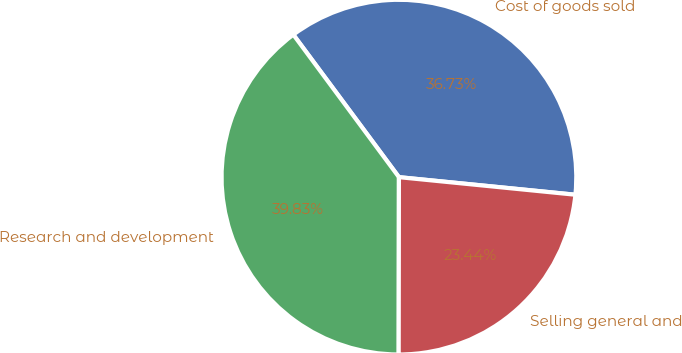<chart> <loc_0><loc_0><loc_500><loc_500><pie_chart><fcel>Cost of goods sold<fcel>Research and development<fcel>Selling general and<nl><fcel>36.73%<fcel>39.83%<fcel>23.44%<nl></chart> 